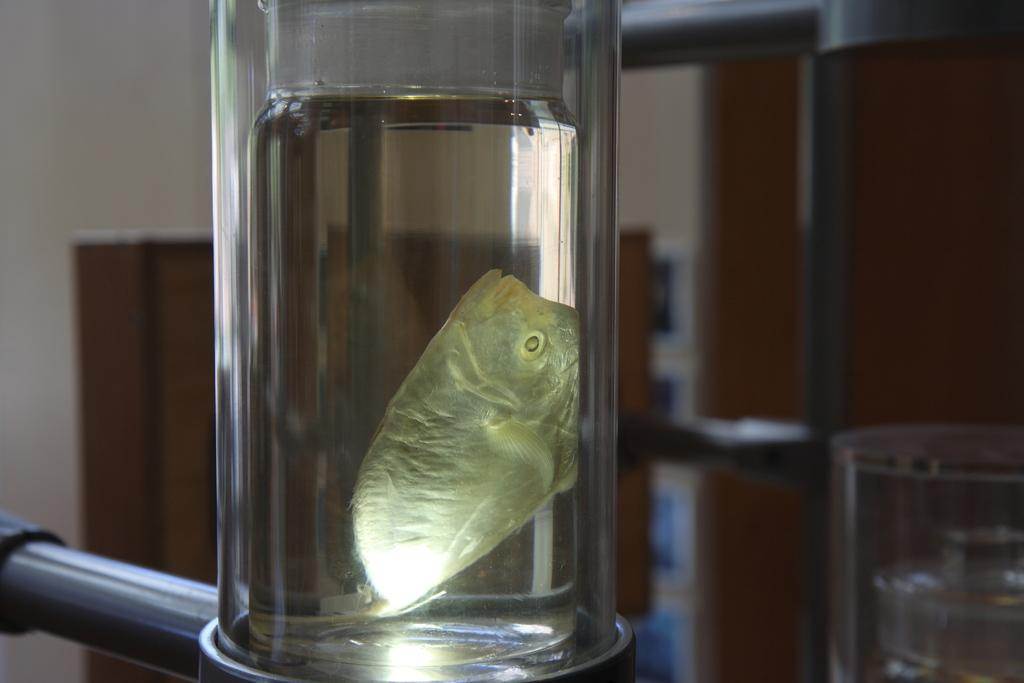What is the main subject in the foreground of the image? There is a fish preserved in a bottle in the foreground of the image. What can be seen in the background of the image? There is a cupboard and a wall in the background of the image. Are there any unclear elements in the background? Yes, some elements in the background are unclear. How does the visitor start following the rule in the image? There is no visitor or rule present in the image; it only features a fish preserved in a bottle and background elements. 